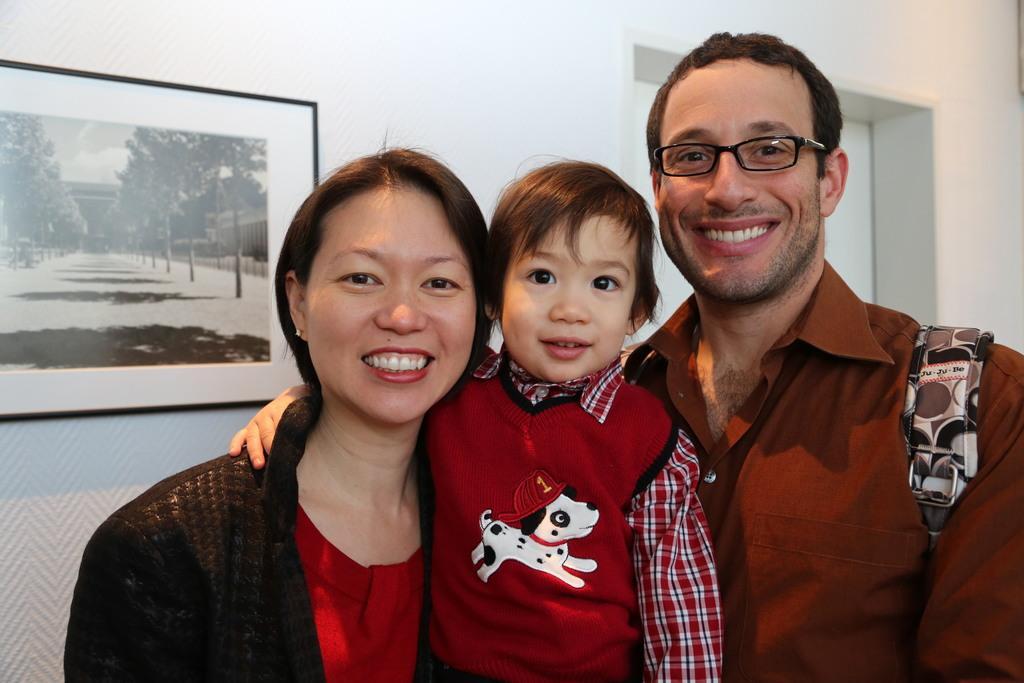Could you give a brief overview of what you see in this image? There are people standing in the foreground area of the image, it seems like a door and a frame in the background. 